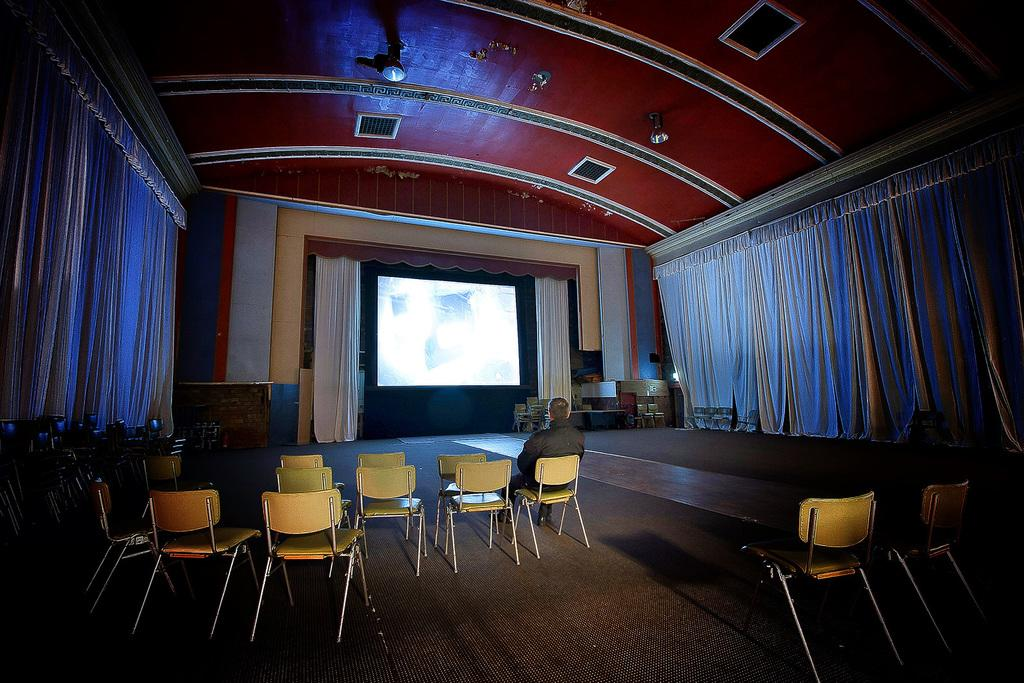What is the man in the image doing? The man is sitting on a chair in the image. How many chairs are visible in the image? There are chairs on the floor in the image. What can be seen in the background of the image? There are curtains, a screen, the ceiling, and walls in the background of the image. Are there any objects visible in the background of the image? Yes, there are some objects in the background of the image. What type of chalk is the man using to write on the screen in the image? There is no chalk or writing activity present in the image. 